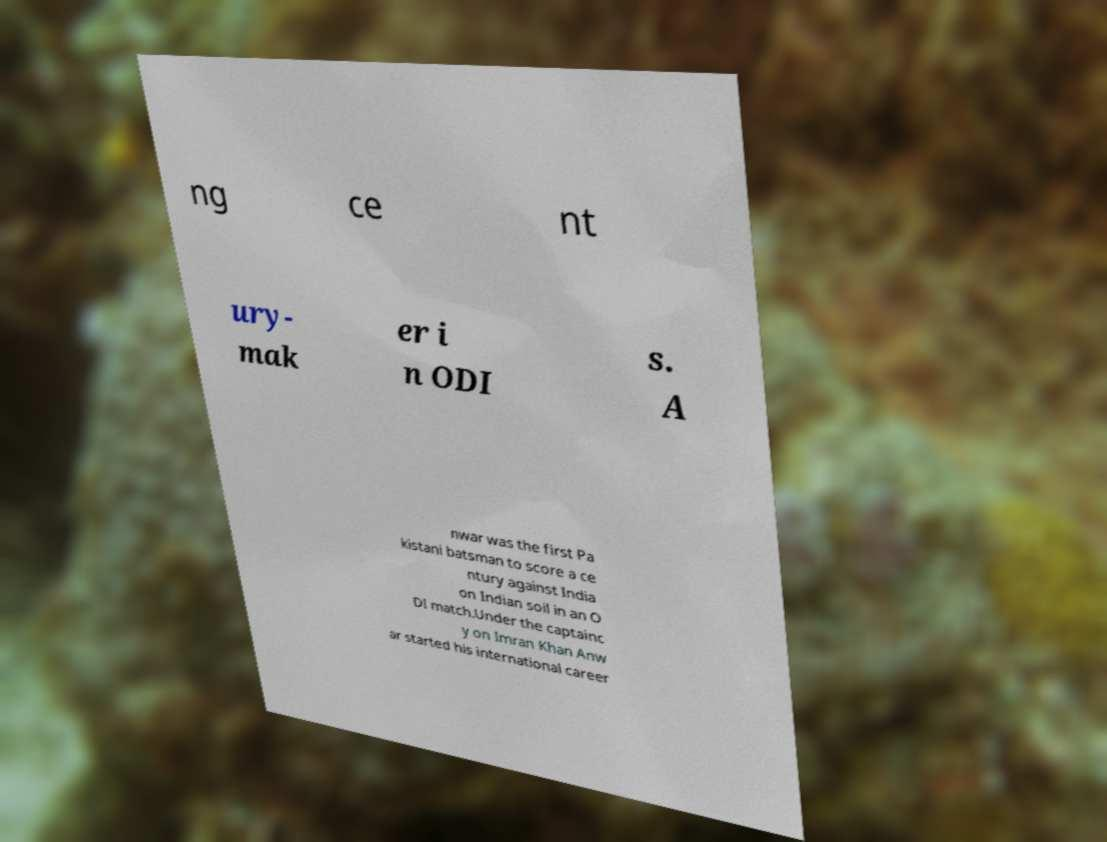I need the written content from this picture converted into text. Can you do that? ng ce nt ury- mak er i n ODI s. A nwar was the first Pa kistani batsman to score a ce ntury against India on Indian soil in an O DI match.Under the captainc y on Imran Khan Anw ar started his international career 